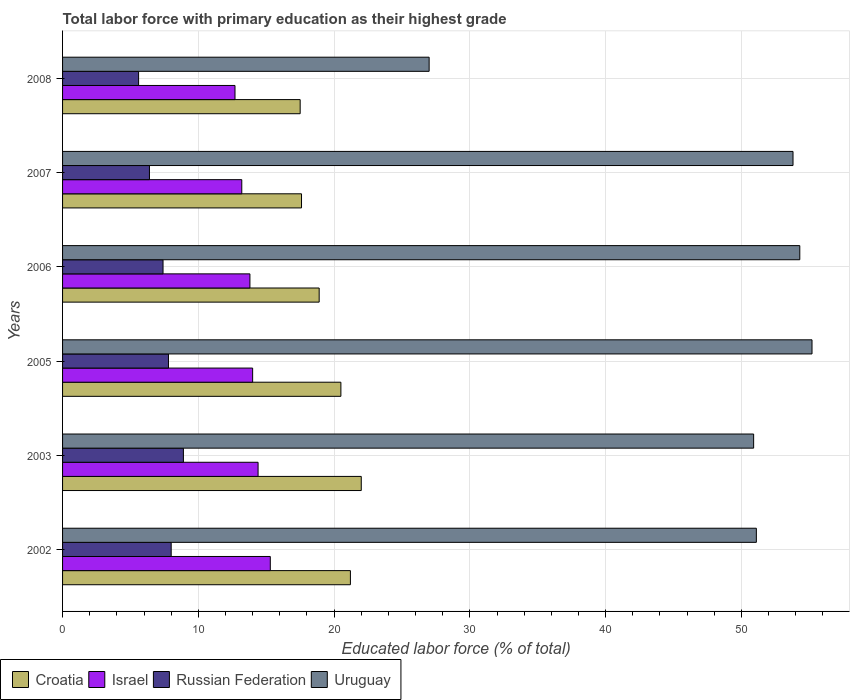How many different coloured bars are there?
Your answer should be very brief. 4. Are the number of bars per tick equal to the number of legend labels?
Your answer should be very brief. Yes. Are the number of bars on each tick of the Y-axis equal?
Provide a short and direct response. Yes. How many bars are there on the 6th tick from the bottom?
Provide a succinct answer. 4. In how many cases, is the number of bars for a given year not equal to the number of legend labels?
Ensure brevity in your answer.  0. What is the percentage of total labor force with primary education in Croatia in 2008?
Keep it short and to the point. 17.5. Across all years, what is the maximum percentage of total labor force with primary education in Russian Federation?
Your response must be concise. 8.9. Across all years, what is the minimum percentage of total labor force with primary education in Russian Federation?
Ensure brevity in your answer.  5.6. In which year was the percentage of total labor force with primary education in Israel maximum?
Make the answer very short. 2002. What is the total percentage of total labor force with primary education in Russian Federation in the graph?
Offer a terse response. 44.1. What is the difference between the percentage of total labor force with primary education in Croatia in 2005 and that in 2006?
Your answer should be compact. 1.6. What is the difference between the percentage of total labor force with primary education in Russian Federation in 2008 and the percentage of total labor force with primary education in Croatia in 2002?
Your response must be concise. -15.6. What is the average percentage of total labor force with primary education in Uruguay per year?
Ensure brevity in your answer.  48.72. In the year 2003, what is the difference between the percentage of total labor force with primary education in Israel and percentage of total labor force with primary education in Uruguay?
Ensure brevity in your answer.  -36.5. What is the ratio of the percentage of total labor force with primary education in Uruguay in 2002 to that in 2005?
Offer a terse response. 0.93. Is the difference between the percentage of total labor force with primary education in Israel in 2006 and 2007 greater than the difference between the percentage of total labor force with primary education in Uruguay in 2006 and 2007?
Your response must be concise. Yes. What is the difference between the highest and the second highest percentage of total labor force with primary education in Croatia?
Offer a terse response. 0.8. What is the difference between the highest and the lowest percentage of total labor force with primary education in Israel?
Your response must be concise. 2.6. Is it the case that in every year, the sum of the percentage of total labor force with primary education in Croatia and percentage of total labor force with primary education in Uruguay is greater than the sum of percentage of total labor force with primary education in Russian Federation and percentage of total labor force with primary education in Israel?
Make the answer very short. No. What does the 4th bar from the top in 2007 represents?
Offer a very short reply. Croatia. What does the 3rd bar from the bottom in 2005 represents?
Your answer should be compact. Russian Federation. Is it the case that in every year, the sum of the percentage of total labor force with primary education in Russian Federation and percentage of total labor force with primary education in Uruguay is greater than the percentage of total labor force with primary education in Croatia?
Keep it short and to the point. Yes. Are all the bars in the graph horizontal?
Provide a succinct answer. Yes. How many years are there in the graph?
Offer a very short reply. 6. What is the difference between two consecutive major ticks on the X-axis?
Provide a short and direct response. 10. Are the values on the major ticks of X-axis written in scientific E-notation?
Give a very brief answer. No. Does the graph contain any zero values?
Make the answer very short. No. Where does the legend appear in the graph?
Make the answer very short. Bottom left. How many legend labels are there?
Keep it short and to the point. 4. What is the title of the graph?
Keep it short and to the point. Total labor force with primary education as their highest grade. Does "Burkina Faso" appear as one of the legend labels in the graph?
Ensure brevity in your answer.  No. What is the label or title of the X-axis?
Your answer should be compact. Educated labor force (% of total). What is the Educated labor force (% of total) in Croatia in 2002?
Your answer should be very brief. 21.2. What is the Educated labor force (% of total) of Israel in 2002?
Your answer should be compact. 15.3. What is the Educated labor force (% of total) of Uruguay in 2002?
Give a very brief answer. 51.1. What is the Educated labor force (% of total) in Croatia in 2003?
Offer a very short reply. 22. What is the Educated labor force (% of total) of Israel in 2003?
Your answer should be compact. 14.4. What is the Educated labor force (% of total) in Russian Federation in 2003?
Keep it short and to the point. 8.9. What is the Educated labor force (% of total) in Uruguay in 2003?
Give a very brief answer. 50.9. What is the Educated labor force (% of total) in Israel in 2005?
Give a very brief answer. 14. What is the Educated labor force (% of total) of Russian Federation in 2005?
Offer a terse response. 7.8. What is the Educated labor force (% of total) in Uruguay in 2005?
Make the answer very short. 55.2. What is the Educated labor force (% of total) of Croatia in 2006?
Ensure brevity in your answer.  18.9. What is the Educated labor force (% of total) of Israel in 2006?
Make the answer very short. 13.8. What is the Educated labor force (% of total) of Russian Federation in 2006?
Keep it short and to the point. 7.4. What is the Educated labor force (% of total) of Uruguay in 2006?
Give a very brief answer. 54.3. What is the Educated labor force (% of total) in Croatia in 2007?
Your response must be concise. 17.6. What is the Educated labor force (% of total) in Israel in 2007?
Your response must be concise. 13.2. What is the Educated labor force (% of total) of Russian Federation in 2007?
Keep it short and to the point. 6.4. What is the Educated labor force (% of total) in Uruguay in 2007?
Your answer should be very brief. 53.8. What is the Educated labor force (% of total) of Israel in 2008?
Offer a very short reply. 12.7. What is the Educated labor force (% of total) of Russian Federation in 2008?
Your answer should be very brief. 5.6. Across all years, what is the maximum Educated labor force (% of total) in Croatia?
Your response must be concise. 22. Across all years, what is the maximum Educated labor force (% of total) in Israel?
Offer a very short reply. 15.3. Across all years, what is the maximum Educated labor force (% of total) in Russian Federation?
Keep it short and to the point. 8.9. Across all years, what is the maximum Educated labor force (% of total) of Uruguay?
Provide a short and direct response. 55.2. Across all years, what is the minimum Educated labor force (% of total) in Israel?
Your answer should be compact. 12.7. Across all years, what is the minimum Educated labor force (% of total) of Russian Federation?
Provide a succinct answer. 5.6. What is the total Educated labor force (% of total) in Croatia in the graph?
Keep it short and to the point. 117.7. What is the total Educated labor force (% of total) of Israel in the graph?
Offer a very short reply. 83.4. What is the total Educated labor force (% of total) of Russian Federation in the graph?
Offer a terse response. 44.1. What is the total Educated labor force (% of total) in Uruguay in the graph?
Ensure brevity in your answer.  292.3. What is the difference between the Educated labor force (% of total) in Israel in 2002 and that in 2003?
Your answer should be compact. 0.9. What is the difference between the Educated labor force (% of total) of Russian Federation in 2002 and that in 2003?
Ensure brevity in your answer.  -0.9. What is the difference between the Educated labor force (% of total) of Croatia in 2002 and that in 2006?
Offer a very short reply. 2.3. What is the difference between the Educated labor force (% of total) in Russian Federation in 2002 and that in 2006?
Offer a very short reply. 0.6. What is the difference between the Educated labor force (% of total) of Uruguay in 2002 and that in 2006?
Keep it short and to the point. -3.2. What is the difference between the Educated labor force (% of total) of Israel in 2002 and that in 2007?
Your answer should be compact. 2.1. What is the difference between the Educated labor force (% of total) in Russian Federation in 2002 and that in 2007?
Your response must be concise. 1.6. What is the difference between the Educated labor force (% of total) of Israel in 2002 and that in 2008?
Offer a very short reply. 2.6. What is the difference between the Educated labor force (% of total) of Russian Federation in 2002 and that in 2008?
Your response must be concise. 2.4. What is the difference between the Educated labor force (% of total) in Uruguay in 2002 and that in 2008?
Your answer should be compact. 24.1. What is the difference between the Educated labor force (% of total) of Croatia in 2003 and that in 2005?
Offer a very short reply. 1.5. What is the difference between the Educated labor force (% of total) of Russian Federation in 2003 and that in 2005?
Offer a very short reply. 1.1. What is the difference between the Educated labor force (% of total) in Croatia in 2003 and that in 2006?
Make the answer very short. 3.1. What is the difference between the Educated labor force (% of total) of Israel in 2003 and that in 2006?
Offer a very short reply. 0.6. What is the difference between the Educated labor force (% of total) of Israel in 2003 and that in 2007?
Your answer should be very brief. 1.2. What is the difference between the Educated labor force (% of total) of Russian Federation in 2003 and that in 2007?
Provide a succinct answer. 2.5. What is the difference between the Educated labor force (% of total) of Uruguay in 2003 and that in 2007?
Give a very brief answer. -2.9. What is the difference between the Educated labor force (% of total) of Russian Federation in 2003 and that in 2008?
Keep it short and to the point. 3.3. What is the difference between the Educated labor force (% of total) in Uruguay in 2003 and that in 2008?
Ensure brevity in your answer.  23.9. What is the difference between the Educated labor force (% of total) in Croatia in 2005 and that in 2006?
Ensure brevity in your answer.  1.6. What is the difference between the Educated labor force (% of total) in Israel in 2005 and that in 2006?
Provide a succinct answer. 0.2. What is the difference between the Educated labor force (% of total) in Uruguay in 2005 and that in 2006?
Offer a terse response. 0.9. What is the difference between the Educated labor force (% of total) of Croatia in 2005 and that in 2007?
Offer a very short reply. 2.9. What is the difference between the Educated labor force (% of total) in Croatia in 2005 and that in 2008?
Ensure brevity in your answer.  3. What is the difference between the Educated labor force (% of total) of Israel in 2005 and that in 2008?
Provide a succinct answer. 1.3. What is the difference between the Educated labor force (% of total) in Russian Federation in 2005 and that in 2008?
Offer a terse response. 2.2. What is the difference between the Educated labor force (% of total) of Uruguay in 2005 and that in 2008?
Give a very brief answer. 28.2. What is the difference between the Educated labor force (% of total) of Croatia in 2006 and that in 2007?
Keep it short and to the point. 1.3. What is the difference between the Educated labor force (% of total) in Israel in 2006 and that in 2007?
Offer a terse response. 0.6. What is the difference between the Educated labor force (% of total) in Russian Federation in 2006 and that in 2008?
Keep it short and to the point. 1.8. What is the difference between the Educated labor force (% of total) of Uruguay in 2006 and that in 2008?
Offer a terse response. 27.3. What is the difference between the Educated labor force (% of total) of Croatia in 2007 and that in 2008?
Your response must be concise. 0.1. What is the difference between the Educated labor force (% of total) in Israel in 2007 and that in 2008?
Your response must be concise. 0.5. What is the difference between the Educated labor force (% of total) in Russian Federation in 2007 and that in 2008?
Keep it short and to the point. 0.8. What is the difference between the Educated labor force (% of total) of Uruguay in 2007 and that in 2008?
Your answer should be very brief. 26.8. What is the difference between the Educated labor force (% of total) in Croatia in 2002 and the Educated labor force (% of total) in Russian Federation in 2003?
Your response must be concise. 12.3. What is the difference between the Educated labor force (% of total) in Croatia in 2002 and the Educated labor force (% of total) in Uruguay in 2003?
Provide a short and direct response. -29.7. What is the difference between the Educated labor force (% of total) of Israel in 2002 and the Educated labor force (% of total) of Uruguay in 2003?
Ensure brevity in your answer.  -35.6. What is the difference between the Educated labor force (% of total) of Russian Federation in 2002 and the Educated labor force (% of total) of Uruguay in 2003?
Give a very brief answer. -42.9. What is the difference between the Educated labor force (% of total) of Croatia in 2002 and the Educated labor force (% of total) of Israel in 2005?
Offer a very short reply. 7.2. What is the difference between the Educated labor force (% of total) of Croatia in 2002 and the Educated labor force (% of total) of Russian Federation in 2005?
Ensure brevity in your answer.  13.4. What is the difference between the Educated labor force (% of total) of Croatia in 2002 and the Educated labor force (% of total) of Uruguay in 2005?
Give a very brief answer. -34. What is the difference between the Educated labor force (% of total) of Israel in 2002 and the Educated labor force (% of total) of Uruguay in 2005?
Your answer should be compact. -39.9. What is the difference between the Educated labor force (% of total) in Russian Federation in 2002 and the Educated labor force (% of total) in Uruguay in 2005?
Your response must be concise. -47.2. What is the difference between the Educated labor force (% of total) in Croatia in 2002 and the Educated labor force (% of total) in Uruguay in 2006?
Your response must be concise. -33.1. What is the difference between the Educated labor force (% of total) in Israel in 2002 and the Educated labor force (% of total) in Russian Federation in 2006?
Your answer should be compact. 7.9. What is the difference between the Educated labor force (% of total) of Israel in 2002 and the Educated labor force (% of total) of Uruguay in 2006?
Your answer should be very brief. -39. What is the difference between the Educated labor force (% of total) of Russian Federation in 2002 and the Educated labor force (% of total) of Uruguay in 2006?
Make the answer very short. -46.3. What is the difference between the Educated labor force (% of total) of Croatia in 2002 and the Educated labor force (% of total) of Uruguay in 2007?
Your answer should be very brief. -32.6. What is the difference between the Educated labor force (% of total) of Israel in 2002 and the Educated labor force (% of total) of Uruguay in 2007?
Offer a terse response. -38.5. What is the difference between the Educated labor force (% of total) in Russian Federation in 2002 and the Educated labor force (% of total) in Uruguay in 2007?
Your response must be concise. -45.8. What is the difference between the Educated labor force (% of total) in Croatia in 2002 and the Educated labor force (% of total) in Israel in 2008?
Your answer should be very brief. 8.5. What is the difference between the Educated labor force (% of total) in Croatia in 2002 and the Educated labor force (% of total) in Russian Federation in 2008?
Provide a short and direct response. 15.6. What is the difference between the Educated labor force (% of total) in Croatia in 2002 and the Educated labor force (% of total) in Uruguay in 2008?
Keep it short and to the point. -5.8. What is the difference between the Educated labor force (% of total) of Israel in 2002 and the Educated labor force (% of total) of Uruguay in 2008?
Give a very brief answer. -11.7. What is the difference between the Educated labor force (% of total) in Russian Federation in 2002 and the Educated labor force (% of total) in Uruguay in 2008?
Provide a short and direct response. -19. What is the difference between the Educated labor force (% of total) of Croatia in 2003 and the Educated labor force (% of total) of Uruguay in 2005?
Give a very brief answer. -33.2. What is the difference between the Educated labor force (% of total) of Israel in 2003 and the Educated labor force (% of total) of Russian Federation in 2005?
Your answer should be very brief. 6.6. What is the difference between the Educated labor force (% of total) of Israel in 2003 and the Educated labor force (% of total) of Uruguay in 2005?
Your response must be concise. -40.8. What is the difference between the Educated labor force (% of total) in Russian Federation in 2003 and the Educated labor force (% of total) in Uruguay in 2005?
Keep it short and to the point. -46.3. What is the difference between the Educated labor force (% of total) in Croatia in 2003 and the Educated labor force (% of total) in Russian Federation in 2006?
Keep it short and to the point. 14.6. What is the difference between the Educated labor force (% of total) of Croatia in 2003 and the Educated labor force (% of total) of Uruguay in 2006?
Your answer should be compact. -32.3. What is the difference between the Educated labor force (% of total) of Israel in 2003 and the Educated labor force (% of total) of Russian Federation in 2006?
Your answer should be compact. 7. What is the difference between the Educated labor force (% of total) of Israel in 2003 and the Educated labor force (% of total) of Uruguay in 2006?
Give a very brief answer. -39.9. What is the difference between the Educated labor force (% of total) in Russian Federation in 2003 and the Educated labor force (% of total) in Uruguay in 2006?
Ensure brevity in your answer.  -45.4. What is the difference between the Educated labor force (% of total) of Croatia in 2003 and the Educated labor force (% of total) of Israel in 2007?
Make the answer very short. 8.8. What is the difference between the Educated labor force (% of total) of Croatia in 2003 and the Educated labor force (% of total) of Russian Federation in 2007?
Provide a short and direct response. 15.6. What is the difference between the Educated labor force (% of total) in Croatia in 2003 and the Educated labor force (% of total) in Uruguay in 2007?
Provide a succinct answer. -31.8. What is the difference between the Educated labor force (% of total) of Israel in 2003 and the Educated labor force (% of total) of Uruguay in 2007?
Provide a short and direct response. -39.4. What is the difference between the Educated labor force (% of total) of Russian Federation in 2003 and the Educated labor force (% of total) of Uruguay in 2007?
Provide a short and direct response. -44.9. What is the difference between the Educated labor force (% of total) in Croatia in 2003 and the Educated labor force (% of total) in Russian Federation in 2008?
Give a very brief answer. 16.4. What is the difference between the Educated labor force (% of total) in Israel in 2003 and the Educated labor force (% of total) in Uruguay in 2008?
Give a very brief answer. -12.6. What is the difference between the Educated labor force (% of total) of Russian Federation in 2003 and the Educated labor force (% of total) of Uruguay in 2008?
Keep it short and to the point. -18.1. What is the difference between the Educated labor force (% of total) of Croatia in 2005 and the Educated labor force (% of total) of Israel in 2006?
Ensure brevity in your answer.  6.7. What is the difference between the Educated labor force (% of total) of Croatia in 2005 and the Educated labor force (% of total) of Russian Federation in 2006?
Your answer should be compact. 13.1. What is the difference between the Educated labor force (% of total) in Croatia in 2005 and the Educated labor force (% of total) in Uruguay in 2006?
Keep it short and to the point. -33.8. What is the difference between the Educated labor force (% of total) of Israel in 2005 and the Educated labor force (% of total) of Russian Federation in 2006?
Your answer should be compact. 6.6. What is the difference between the Educated labor force (% of total) in Israel in 2005 and the Educated labor force (% of total) in Uruguay in 2006?
Your answer should be compact. -40.3. What is the difference between the Educated labor force (% of total) of Russian Federation in 2005 and the Educated labor force (% of total) of Uruguay in 2006?
Your response must be concise. -46.5. What is the difference between the Educated labor force (% of total) in Croatia in 2005 and the Educated labor force (% of total) in Russian Federation in 2007?
Your response must be concise. 14.1. What is the difference between the Educated labor force (% of total) of Croatia in 2005 and the Educated labor force (% of total) of Uruguay in 2007?
Provide a short and direct response. -33.3. What is the difference between the Educated labor force (% of total) of Israel in 2005 and the Educated labor force (% of total) of Russian Federation in 2007?
Your answer should be compact. 7.6. What is the difference between the Educated labor force (% of total) of Israel in 2005 and the Educated labor force (% of total) of Uruguay in 2007?
Ensure brevity in your answer.  -39.8. What is the difference between the Educated labor force (% of total) in Russian Federation in 2005 and the Educated labor force (% of total) in Uruguay in 2007?
Your answer should be compact. -46. What is the difference between the Educated labor force (% of total) in Croatia in 2005 and the Educated labor force (% of total) in Israel in 2008?
Keep it short and to the point. 7.8. What is the difference between the Educated labor force (% of total) in Croatia in 2005 and the Educated labor force (% of total) in Uruguay in 2008?
Provide a succinct answer. -6.5. What is the difference between the Educated labor force (% of total) of Israel in 2005 and the Educated labor force (% of total) of Russian Federation in 2008?
Give a very brief answer. 8.4. What is the difference between the Educated labor force (% of total) in Russian Federation in 2005 and the Educated labor force (% of total) in Uruguay in 2008?
Provide a succinct answer. -19.2. What is the difference between the Educated labor force (% of total) of Croatia in 2006 and the Educated labor force (% of total) of Uruguay in 2007?
Give a very brief answer. -34.9. What is the difference between the Educated labor force (% of total) in Israel in 2006 and the Educated labor force (% of total) in Uruguay in 2007?
Offer a terse response. -40. What is the difference between the Educated labor force (% of total) of Russian Federation in 2006 and the Educated labor force (% of total) of Uruguay in 2007?
Ensure brevity in your answer.  -46.4. What is the difference between the Educated labor force (% of total) in Croatia in 2006 and the Educated labor force (% of total) in Russian Federation in 2008?
Your answer should be very brief. 13.3. What is the difference between the Educated labor force (% of total) in Croatia in 2006 and the Educated labor force (% of total) in Uruguay in 2008?
Offer a very short reply. -8.1. What is the difference between the Educated labor force (% of total) of Russian Federation in 2006 and the Educated labor force (% of total) of Uruguay in 2008?
Give a very brief answer. -19.6. What is the difference between the Educated labor force (% of total) of Croatia in 2007 and the Educated labor force (% of total) of Uruguay in 2008?
Make the answer very short. -9.4. What is the difference between the Educated labor force (% of total) of Russian Federation in 2007 and the Educated labor force (% of total) of Uruguay in 2008?
Provide a succinct answer. -20.6. What is the average Educated labor force (% of total) of Croatia per year?
Provide a short and direct response. 19.62. What is the average Educated labor force (% of total) of Israel per year?
Give a very brief answer. 13.9. What is the average Educated labor force (% of total) of Russian Federation per year?
Give a very brief answer. 7.35. What is the average Educated labor force (% of total) in Uruguay per year?
Provide a succinct answer. 48.72. In the year 2002, what is the difference between the Educated labor force (% of total) in Croatia and Educated labor force (% of total) in Israel?
Keep it short and to the point. 5.9. In the year 2002, what is the difference between the Educated labor force (% of total) of Croatia and Educated labor force (% of total) of Uruguay?
Keep it short and to the point. -29.9. In the year 2002, what is the difference between the Educated labor force (% of total) in Israel and Educated labor force (% of total) in Russian Federation?
Your answer should be very brief. 7.3. In the year 2002, what is the difference between the Educated labor force (% of total) of Israel and Educated labor force (% of total) of Uruguay?
Offer a very short reply. -35.8. In the year 2002, what is the difference between the Educated labor force (% of total) in Russian Federation and Educated labor force (% of total) in Uruguay?
Your answer should be compact. -43.1. In the year 2003, what is the difference between the Educated labor force (% of total) in Croatia and Educated labor force (% of total) in Israel?
Provide a succinct answer. 7.6. In the year 2003, what is the difference between the Educated labor force (% of total) of Croatia and Educated labor force (% of total) of Russian Federation?
Your answer should be compact. 13.1. In the year 2003, what is the difference between the Educated labor force (% of total) of Croatia and Educated labor force (% of total) of Uruguay?
Ensure brevity in your answer.  -28.9. In the year 2003, what is the difference between the Educated labor force (% of total) of Israel and Educated labor force (% of total) of Russian Federation?
Your answer should be compact. 5.5. In the year 2003, what is the difference between the Educated labor force (% of total) in Israel and Educated labor force (% of total) in Uruguay?
Your answer should be compact. -36.5. In the year 2003, what is the difference between the Educated labor force (% of total) of Russian Federation and Educated labor force (% of total) of Uruguay?
Your response must be concise. -42. In the year 2005, what is the difference between the Educated labor force (% of total) in Croatia and Educated labor force (% of total) in Israel?
Give a very brief answer. 6.5. In the year 2005, what is the difference between the Educated labor force (% of total) in Croatia and Educated labor force (% of total) in Uruguay?
Offer a terse response. -34.7. In the year 2005, what is the difference between the Educated labor force (% of total) of Israel and Educated labor force (% of total) of Uruguay?
Ensure brevity in your answer.  -41.2. In the year 2005, what is the difference between the Educated labor force (% of total) in Russian Federation and Educated labor force (% of total) in Uruguay?
Your answer should be very brief. -47.4. In the year 2006, what is the difference between the Educated labor force (% of total) in Croatia and Educated labor force (% of total) in Russian Federation?
Keep it short and to the point. 11.5. In the year 2006, what is the difference between the Educated labor force (% of total) in Croatia and Educated labor force (% of total) in Uruguay?
Offer a very short reply. -35.4. In the year 2006, what is the difference between the Educated labor force (% of total) in Israel and Educated labor force (% of total) in Uruguay?
Your response must be concise. -40.5. In the year 2006, what is the difference between the Educated labor force (% of total) in Russian Federation and Educated labor force (% of total) in Uruguay?
Provide a succinct answer. -46.9. In the year 2007, what is the difference between the Educated labor force (% of total) of Croatia and Educated labor force (% of total) of Israel?
Give a very brief answer. 4.4. In the year 2007, what is the difference between the Educated labor force (% of total) in Croatia and Educated labor force (% of total) in Russian Federation?
Your response must be concise. 11.2. In the year 2007, what is the difference between the Educated labor force (% of total) of Croatia and Educated labor force (% of total) of Uruguay?
Ensure brevity in your answer.  -36.2. In the year 2007, what is the difference between the Educated labor force (% of total) in Israel and Educated labor force (% of total) in Uruguay?
Give a very brief answer. -40.6. In the year 2007, what is the difference between the Educated labor force (% of total) of Russian Federation and Educated labor force (% of total) of Uruguay?
Make the answer very short. -47.4. In the year 2008, what is the difference between the Educated labor force (% of total) of Croatia and Educated labor force (% of total) of Israel?
Your response must be concise. 4.8. In the year 2008, what is the difference between the Educated labor force (% of total) in Croatia and Educated labor force (% of total) in Uruguay?
Give a very brief answer. -9.5. In the year 2008, what is the difference between the Educated labor force (% of total) of Israel and Educated labor force (% of total) of Uruguay?
Your answer should be compact. -14.3. In the year 2008, what is the difference between the Educated labor force (% of total) of Russian Federation and Educated labor force (% of total) of Uruguay?
Offer a terse response. -21.4. What is the ratio of the Educated labor force (% of total) of Croatia in 2002 to that in 2003?
Provide a succinct answer. 0.96. What is the ratio of the Educated labor force (% of total) of Israel in 2002 to that in 2003?
Keep it short and to the point. 1.06. What is the ratio of the Educated labor force (% of total) in Russian Federation in 2002 to that in 2003?
Your answer should be compact. 0.9. What is the ratio of the Educated labor force (% of total) of Croatia in 2002 to that in 2005?
Give a very brief answer. 1.03. What is the ratio of the Educated labor force (% of total) of Israel in 2002 to that in 2005?
Offer a terse response. 1.09. What is the ratio of the Educated labor force (% of total) in Russian Federation in 2002 to that in 2005?
Your response must be concise. 1.03. What is the ratio of the Educated labor force (% of total) in Uruguay in 2002 to that in 2005?
Provide a short and direct response. 0.93. What is the ratio of the Educated labor force (% of total) of Croatia in 2002 to that in 2006?
Offer a terse response. 1.12. What is the ratio of the Educated labor force (% of total) of Israel in 2002 to that in 2006?
Offer a terse response. 1.11. What is the ratio of the Educated labor force (% of total) in Russian Federation in 2002 to that in 2006?
Give a very brief answer. 1.08. What is the ratio of the Educated labor force (% of total) in Uruguay in 2002 to that in 2006?
Ensure brevity in your answer.  0.94. What is the ratio of the Educated labor force (% of total) of Croatia in 2002 to that in 2007?
Your answer should be compact. 1.2. What is the ratio of the Educated labor force (% of total) of Israel in 2002 to that in 2007?
Keep it short and to the point. 1.16. What is the ratio of the Educated labor force (% of total) in Uruguay in 2002 to that in 2007?
Your response must be concise. 0.95. What is the ratio of the Educated labor force (% of total) in Croatia in 2002 to that in 2008?
Provide a succinct answer. 1.21. What is the ratio of the Educated labor force (% of total) in Israel in 2002 to that in 2008?
Give a very brief answer. 1.2. What is the ratio of the Educated labor force (% of total) of Russian Federation in 2002 to that in 2008?
Your response must be concise. 1.43. What is the ratio of the Educated labor force (% of total) of Uruguay in 2002 to that in 2008?
Keep it short and to the point. 1.89. What is the ratio of the Educated labor force (% of total) of Croatia in 2003 to that in 2005?
Your answer should be very brief. 1.07. What is the ratio of the Educated labor force (% of total) in Israel in 2003 to that in 2005?
Make the answer very short. 1.03. What is the ratio of the Educated labor force (% of total) in Russian Federation in 2003 to that in 2005?
Make the answer very short. 1.14. What is the ratio of the Educated labor force (% of total) of Uruguay in 2003 to that in 2005?
Your answer should be very brief. 0.92. What is the ratio of the Educated labor force (% of total) in Croatia in 2003 to that in 2006?
Provide a succinct answer. 1.16. What is the ratio of the Educated labor force (% of total) in Israel in 2003 to that in 2006?
Your answer should be compact. 1.04. What is the ratio of the Educated labor force (% of total) in Russian Federation in 2003 to that in 2006?
Make the answer very short. 1.2. What is the ratio of the Educated labor force (% of total) of Uruguay in 2003 to that in 2006?
Offer a terse response. 0.94. What is the ratio of the Educated labor force (% of total) of Croatia in 2003 to that in 2007?
Make the answer very short. 1.25. What is the ratio of the Educated labor force (% of total) in Israel in 2003 to that in 2007?
Your answer should be compact. 1.09. What is the ratio of the Educated labor force (% of total) in Russian Federation in 2003 to that in 2007?
Provide a short and direct response. 1.39. What is the ratio of the Educated labor force (% of total) in Uruguay in 2003 to that in 2007?
Give a very brief answer. 0.95. What is the ratio of the Educated labor force (% of total) of Croatia in 2003 to that in 2008?
Give a very brief answer. 1.26. What is the ratio of the Educated labor force (% of total) in Israel in 2003 to that in 2008?
Your response must be concise. 1.13. What is the ratio of the Educated labor force (% of total) in Russian Federation in 2003 to that in 2008?
Your answer should be compact. 1.59. What is the ratio of the Educated labor force (% of total) of Uruguay in 2003 to that in 2008?
Provide a succinct answer. 1.89. What is the ratio of the Educated labor force (% of total) in Croatia in 2005 to that in 2006?
Your answer should be compact. 1.08. What is the ratio of the Educated labor force (% of total) of Israel in 2005 to that in 2006?
Give a very brief answer. 1.01. What is the ratio of the Educated labor force (% of total) of Russian Federation in 2005 to that in 2006?
Your answer should be very brief. 1.05. What is the ratio of the Educated labor force (% of total) of Uruguay in 2005 to that in 2006?
Your answer should be very brief. 1.02. What is the ratio of the Educated labor force (% of total) in Croatia in 2005 to that in 2007?
Your response must be concise. 1.16. What is the ratio of the Educated labor force (% of total) in Israel in 2005 to that in 2007?
Your response must be concise. 1.06. What is the ratio of the Educated labor force (% of total) of Russian Federation in 2005 to that in 2007?
Offer a very short reply. 1.22. What is the ratio of the Educated labor force (% of total) in Croatia in 2005 to that in 2008?
Make the answer very short. 1.17. What is the ratio of the Educated labor force (% of total) in Israel in 2005 to that in 2008?
Make the answer very short. 1.1. What is the ratio of the Educated labor force (% of total) in Russian Federation in 2005 to that in 2008?
Your response must be concise. 1.39. What is the ratio of the Educated labor force (% of total) of Uruguay in 2005 to that in 2008?
Ensure brevity in your answer.  2.04. What is the ratio of the Educated labor force (% of total) in Croatia in 2006 to that in 2007?
Give a very brief answer. 1.07. What is the ratio of the Educated labor force (% of total) in Israel in 2006 to that in 2007?
Give a very brief answer. 1.05. What is the ratio of the Educated labor force (% of total) of Russian Federation in 2006 to that in 2007?
Your response must be concise. 1.16. What is the ratio of the Educated labor force (% of total) in Uruguay in 2006 to that in 2007?
Your response must be concise. 1.01. What is the ratio of the Educated labor force (% of total) in Croatia in 2006 to that in 2008?
Offer a very short reply. 1.08. What is the ratio of the Educated labor force (% of total) of Israel in 2006 to that in 2008?
Your response must be concise. 1.09. What is the ratio of the Educated labor force (% of total) of Russian Federation in 2006 to that in 2008?
Your answer should be compact. 1.32. What is the ratio of the Educated labor force (% of total) of Uruguay in 2006 to that in 2008?
Offer a terse response. 2.01. What is the ratio of the Educated labor force (% of total) in Israel in 2007 to that in 2008?
Make the answer very short. 1.04. What is the ratio of the Educated labor force (% of total) of Uruguay in 2007 to that in 2008?
Your answer should be compact. 1.99. What is the difference between the highest and the second highest Educated labor force (% of total) in Croatia?
Provide a succinct answer. 0.8. What is the difference between the highest and the second highest Educated labor force (% of total) in Israel?
Keep it short and to the point. 0.9. What is the difference between the highest and the second highest Educated labor force (% of total) in Russian Federation?
Provide a succinct answer. 0.9. What is the difference between the highest and the second highest Educated labor force (% of total) in Uruguay?
Your response must be concise. 0.9. What is the difference between the highest and the lowest Educated labor force (% of total) of Croatia?
Offer a terse response. 4.5. What is the difference between the highest and the lowest Educated labor force (% of total) in Israel?
Give a very brief answer. 2.6. What is the difference between the highest and the lowest Educated labor force (% of total) of Russian Federation?
Provide a succinct answer. 3.3. What is the difference between the highest and the lowest Educated labor force (% of total) of Uruguay?
Your answer should be very brief. 28.2. 